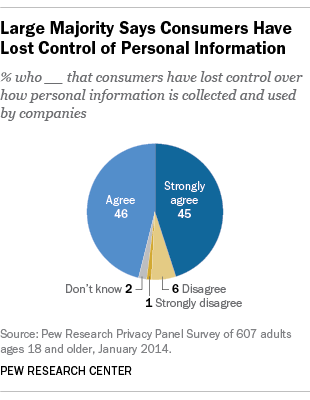Outline some significant characteristics in this image. The value of Agree being greater than Strongly Agree is approximately 1.0222222... 